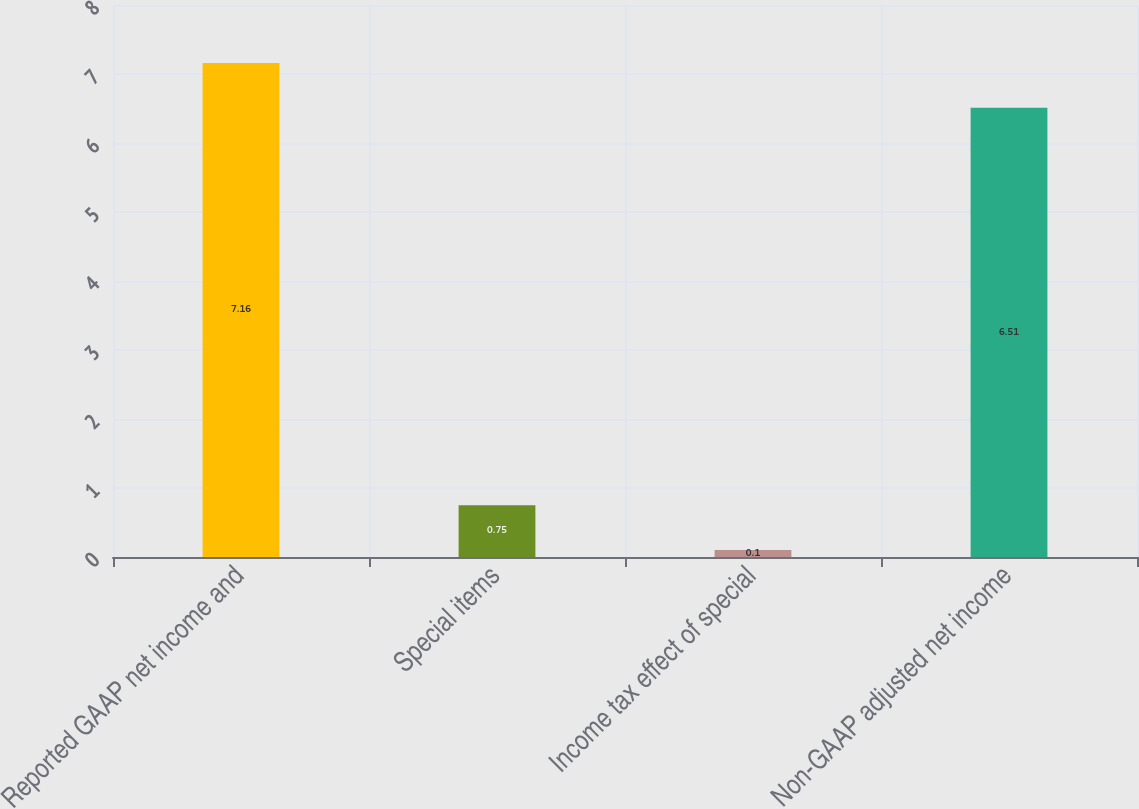<chart> <loc_0><loc_0><loc_500><loc_500><bar_chart><fcel>Reported GAAP net income and<fcel>Special items<fcel>Income tax effect of special<fcel>Non-GAAP adjusted net income<nl><fcel>7.16<fcel>0.75<fcel>0.1<fcel>6.51<nl></chart> 